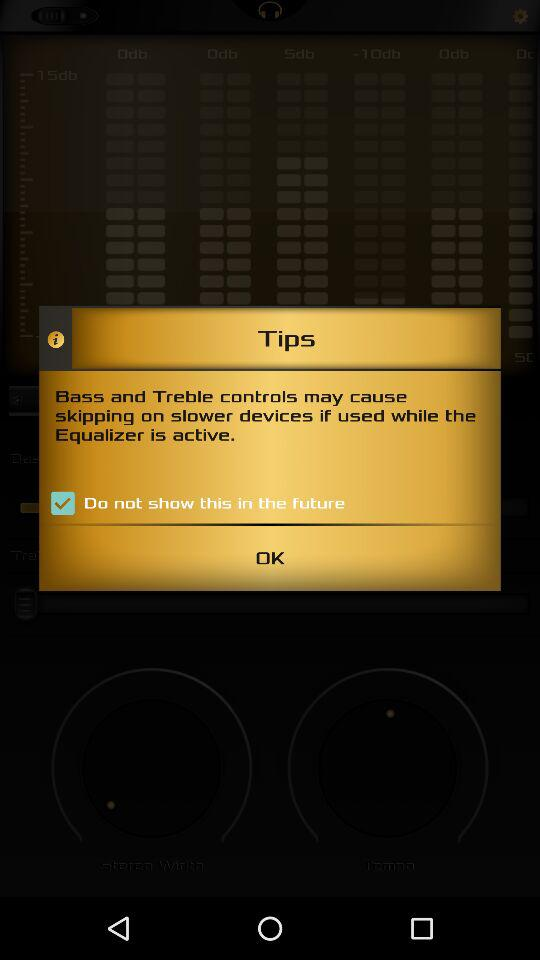What is the name of the application?
When the provided information is insufficient, respond with <no answer>. <no answer> 